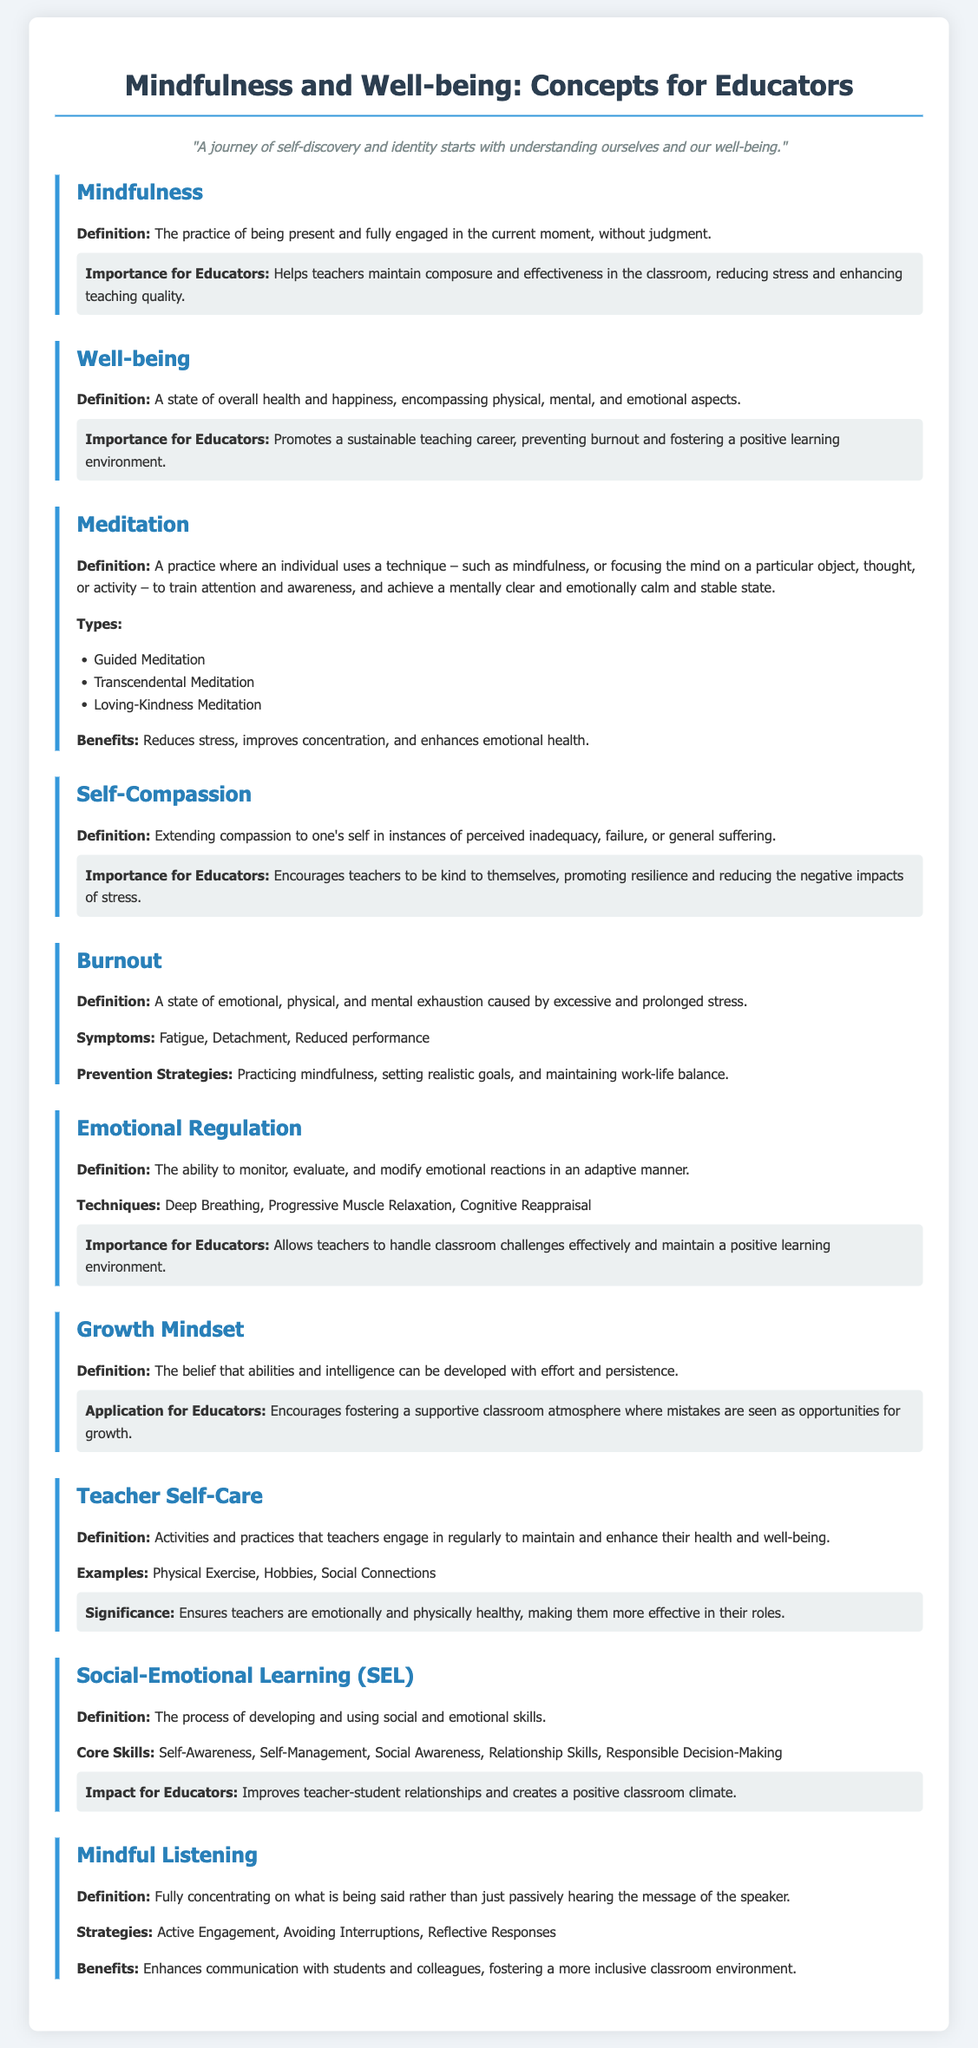What is the definition of mindfulness? Mindfulness is defined as the practice of being present and fully engaged in the current moment, without judgment.
Answer: The practice of being present and fully engaged in the current moment, without judgment What is one benefit of meditation? The document lists benefits of meditation, including that it reduces stress.
Answer: Reduces stress What are two types of meditation mentioned? The document lists types of meditation, including Guided Meditation and Loving-Kindness Meditation.
Answer: Guided Meditation, Loving-Kindness Meditation What does self-compassion encourage for educators? The document states that self-compassion encourages teachers to be kind to themselves.
Answer: Encourages teachers to be kind to themselves What are three symptoms of burnout? The symptoms of burnout listed in the document include fatigue, detachment, and reduced performance.
Answer: Fatigue, Detachment, Reduced performance How does emotional regulation benefit educators? The document explains that emotional regulation allows teachers to handle classroom challenges effectively.
Answer: Allows teachers to handle classroom challenges effectively What is the significance of teacher self-care? The document indicates that teacher self-care ensures teachers are emotionally and physically healthy.
Answer: Ensures teachers are emotionally and physically healthy What does social-emotional learning (SEL) develop? The document states that social-emotional learning develops social and emotional skills.
Answer: Develops social and emotional skills How many core skills are mentioned in social-emotional learning? The document specifies that there are five core skills in social-emotional learning.
Answer: Five 